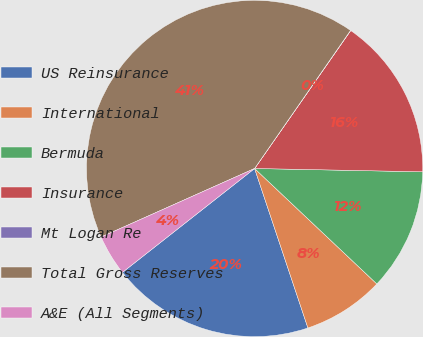Convert chart to OTSL. <chart><loc_0><loc_0><loc_500><loc_500><pie_chart><fcel>US Reinsurance<fcel>International<fcel>Bermuda<fcel>Insurance<fcel>Mt Logan Re<fcel>Total Gross Reserves<fcel>A&E (All Segments)<nl><fcel>19.53%<fcel>7.82%<fcel>11.73%<fcel>15.63%<fcel>0.02%<fcel>41.35%<fcel>3.92%<nl></chart> 